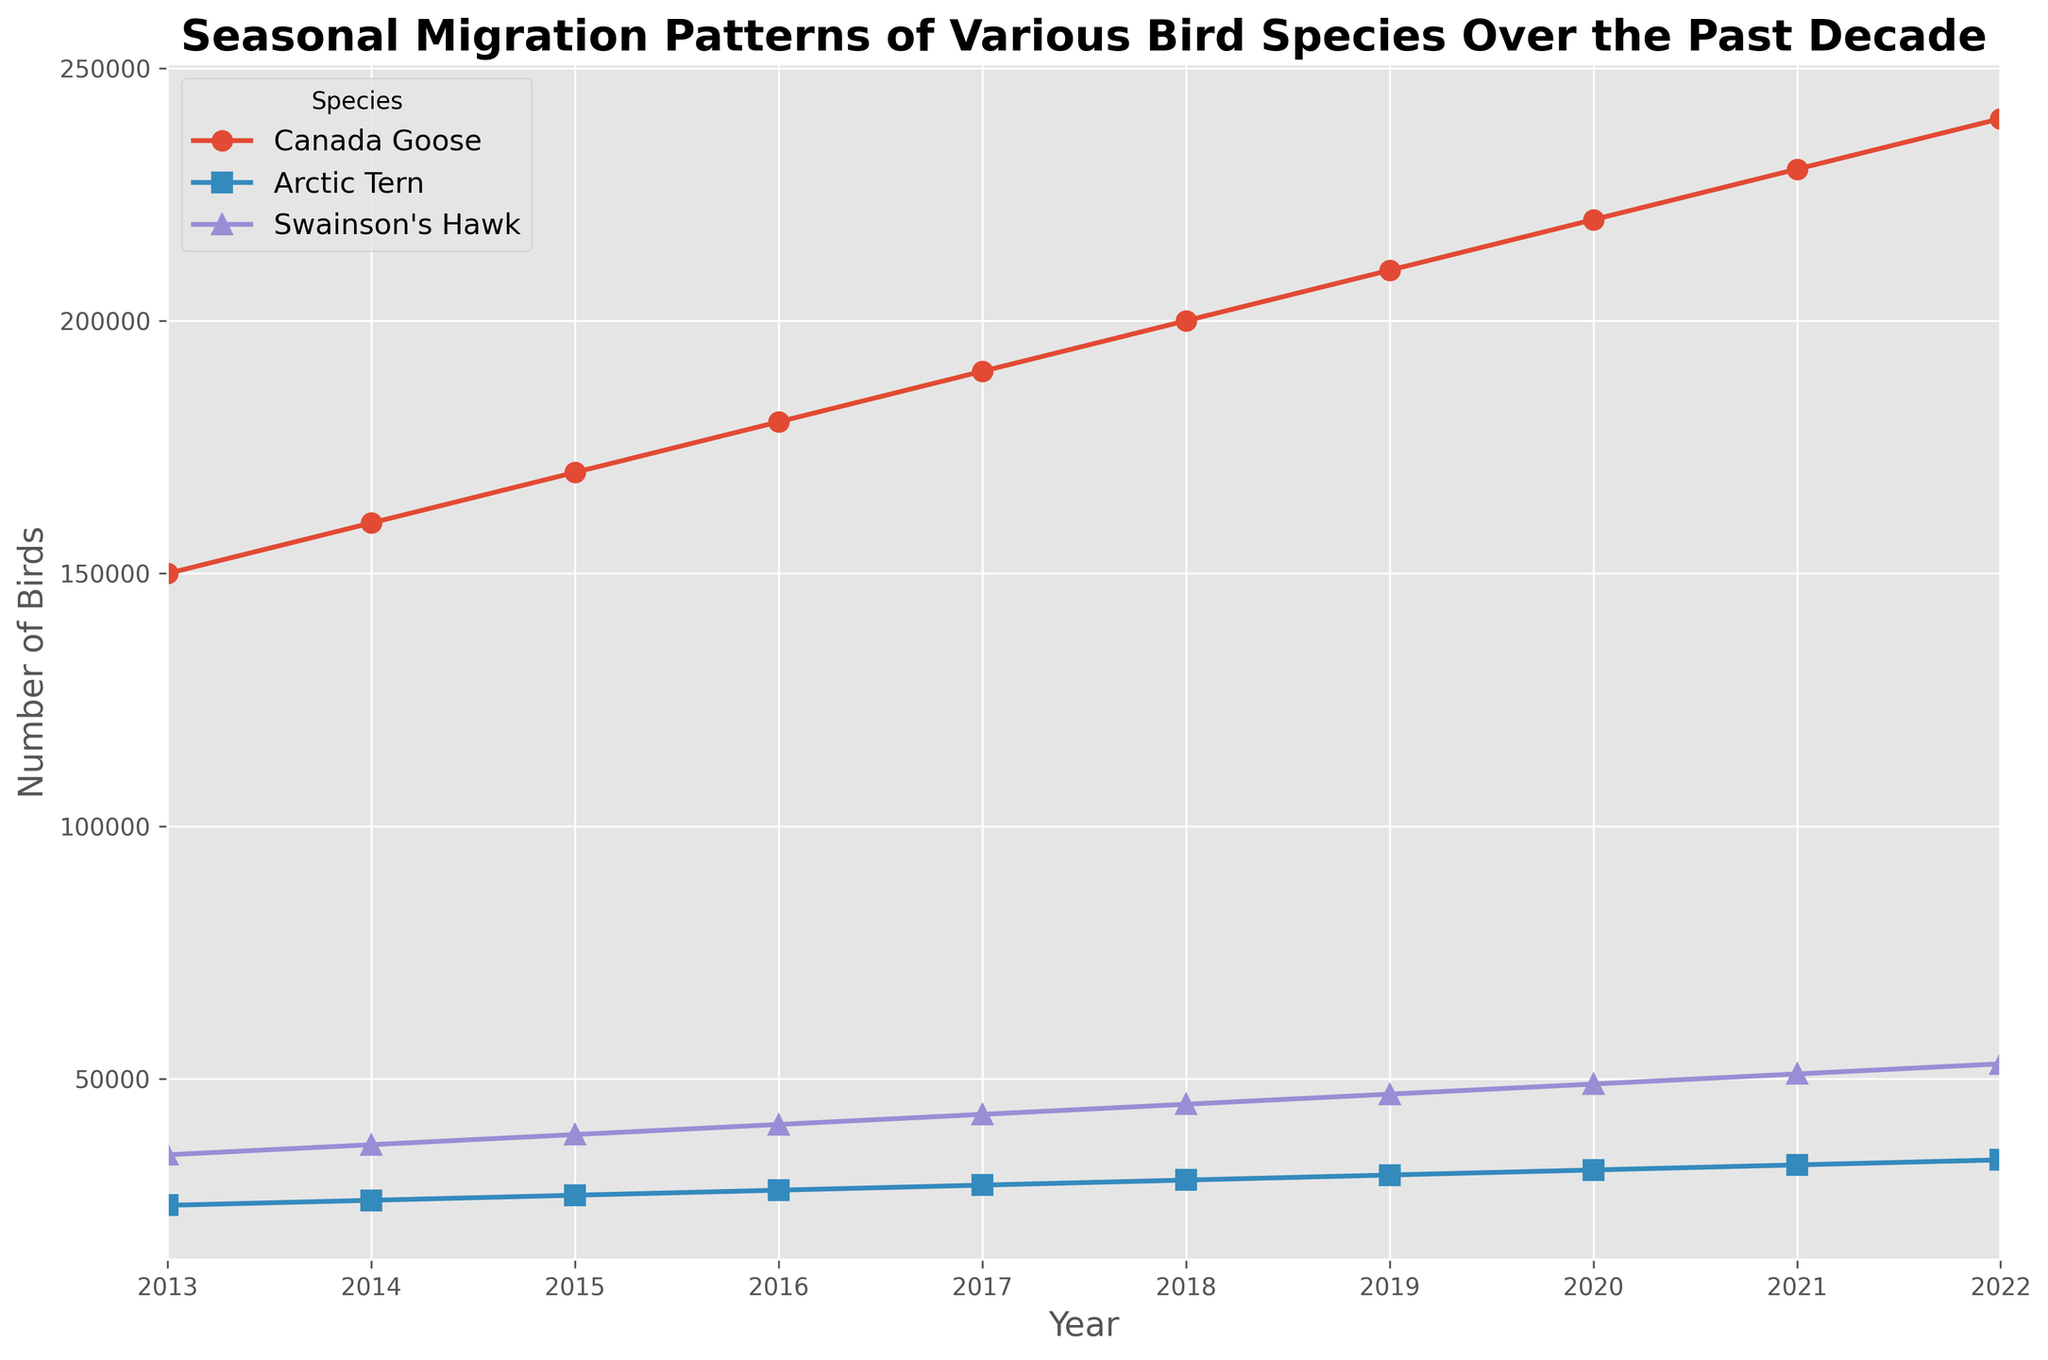What trend do we see in the number of Canada Geese over the past decade? We can observe that the number of Canada Geese consistently increases every year from 2013 to 2022 on the line chart. Starting from 150,000 in 2013, the population steadily rises to 240,000 in 2022.
Answer: Consistently increasing Which bird species had the largest population increase from 2013 to 2022? To determine which bird species had the largest population increase, we calculate the difference in the number of birds from 2013 to 2022 for each species. Canada Goose: 240,000 - 150,000 = 90,000; Arctic Tern: 34,000 - 25,000 = 9,000; Swainson's Hawk: 53,000 - 35,000 = 18,000. The Canada Goose had the largest increase.
Answer: Canada Goose In which year do the Arctic Tern and Swainson's Hawk populations show the same rate of increase? By examining the yearly increments, we find the rates of increase for each species. The Arctic Tern population increases by 1,000 yearly, and Swainson's Hawk increases by 2,000 yearly. The year-to-year comparison shows that both had a 1,000 increase each from 2018 to 2019.
Answer: 2019 What is the average number of Canada Geese from 2013 to 2022? To find the average, we sum the populations of Canada Geese over the years and divide by the number of years. (150,000 + 160,000 + 170,000 + 180,000 + 190,000 + 200,000 + 210,000 + 220,000 + 230,000 + 240,000) / 10 = 1,950,000 / 10 = 195,000
Answer: 195,000 Which year had the smallest population for Swainson's Hawk? By examining the plot, we can see the Swainson's Hawk population starts at 35,000 in 2013 and increases every year. Therefore, 2013 had the smallest population.
Answer: 2013 How much did the Arctic Tern population grow from 2016 to 2020? We find the difference between the number of birds in 2020 and 2016 for Arctic Terns. 32,000 (2020) - 28,000 (2016) = 4,000
Answer: 4,000 Which species shows a linear growth trend in their population over the years? Observing the plot, all species appear to show a consistent linear growth, but Canada Goose and Swainson's Hawk follow a strictly linear pattern.
Answer: Canada Goose Compare the population of Swainson's Hawk in 2015 and Canada Geese in 2014. Which was higher? In 2015, the Swainson's Hawk population was 39,000. In 2014, the Canada Goose population was 160,000. By comparing these numbers, we see that the Canada Goose population was higher in 2014.
Answer: Canada Goose in 2014 From 2018 to 2021, which species experienced the steepest growth rate? By calculating the growth take for each species during these years: 
Canada Goose: 230,000 - 200,000 = 30,000, 
Arctic Tern: 33,000 - 30,000 = 3,000, 
Swainson's Hawk: 51,000 - 45,000 = 6,000.
Canada Goose had the most significant increase.
Answer: Canada Goose 